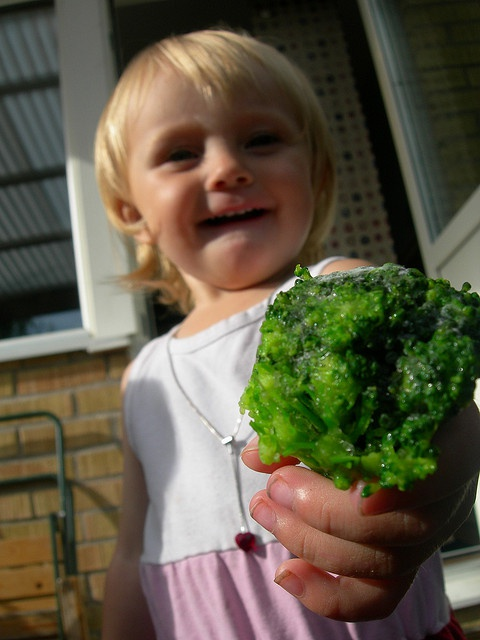Describe the objects in this image and their specific colors. I can see people in darkgreen, black, lightgray, maroon, and brown tones and broccoli in darkgreen, black, and green tones in this image. 